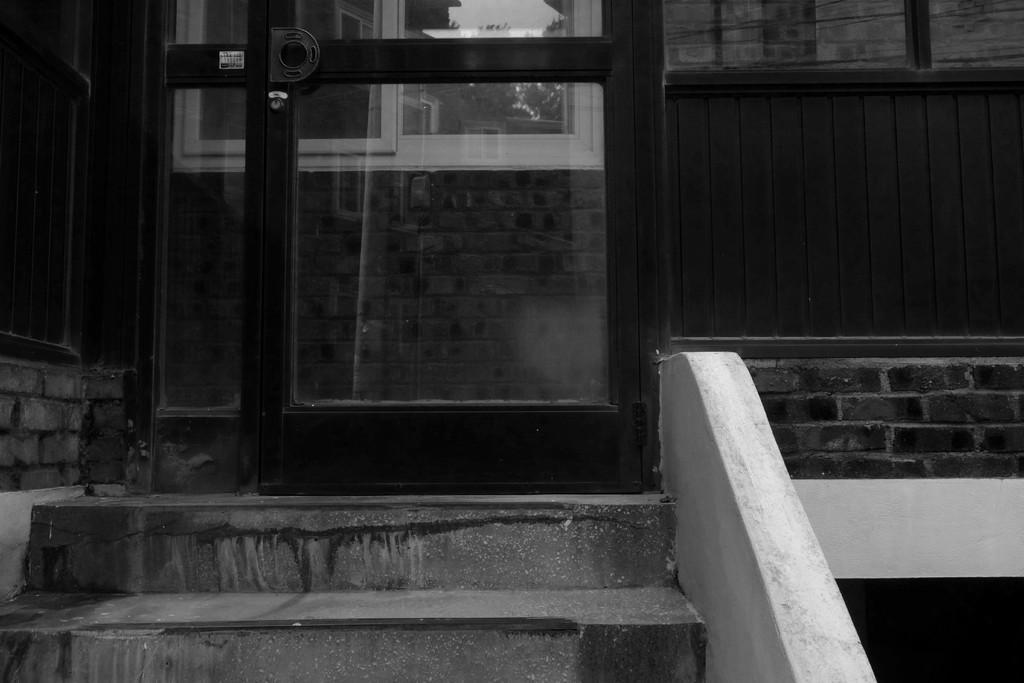How would you summarize this image in a sentence or two? In this image we can see a black and white picture of a building. In the foreground we can see a door, a window and a staircase. 